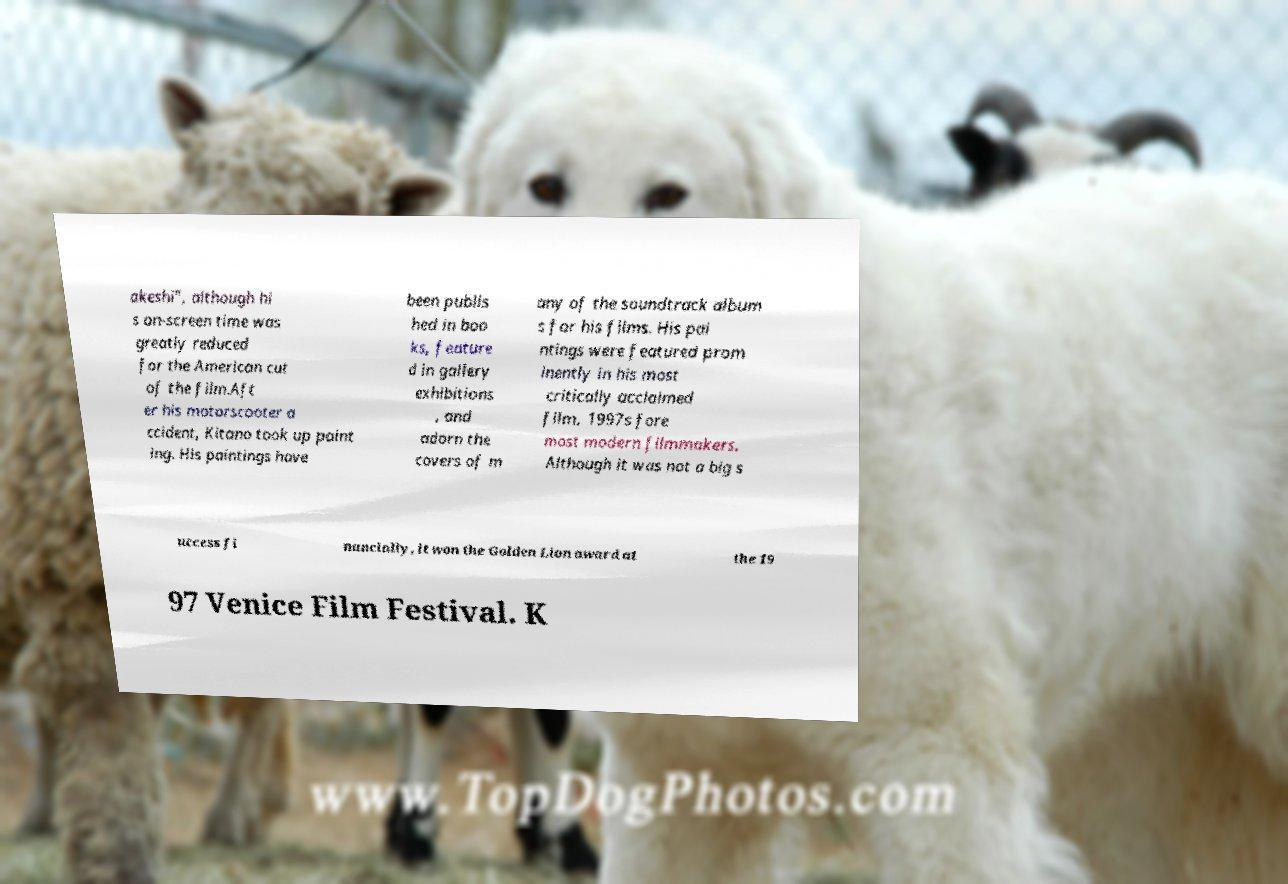Please read and relay the text visible in this image. What does it say? akeshi", although hi s on-screen time was greatly reduced for the American cut of the film.Aft er his motorscooter a ccident, Kitano took up paint ing. His paintings have been publis hed in boo ks, feature d in gallery exhibitions , and adorn the covers of m any of the soundtrack album s for his films. His pai ntings were featured prom inently in his most critically acclaimed film, 1997s fore most modern filmmakers. Although it was not a big s uccess fi nancially, it won the Golden Lion award at the 19 97 Venice Film Festival. K 